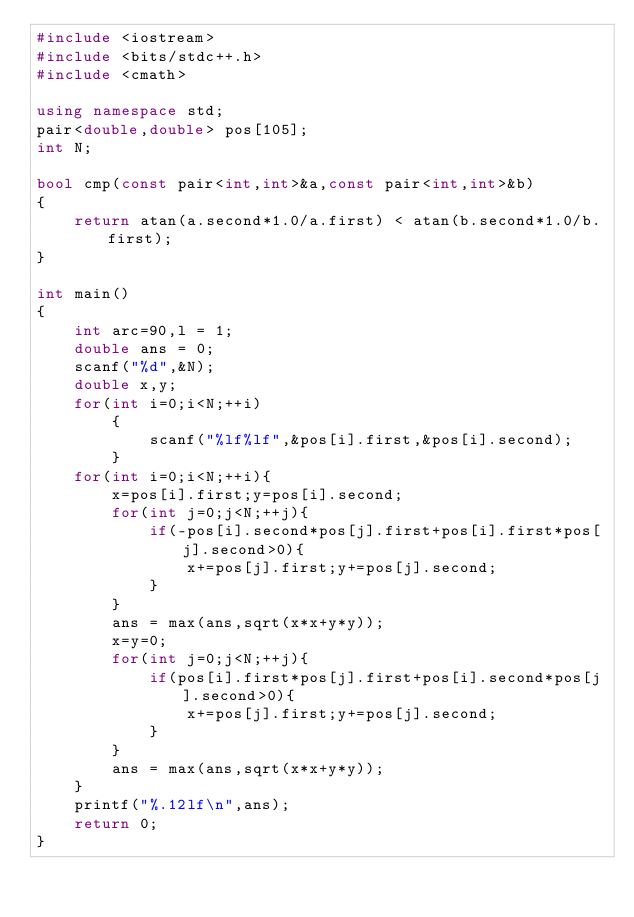<code> <loc_0><loc_0><loc_500><loc_500><_C++_>#include <iostream>
#include <bits/stdc++.h>
#include <cmath>

using namespace std;
pair<double,double> pos[105];
int N;

bool cmp(const pair<int,int>&a,const pair<int,int>&b)
{
    return atan(a.second*1.0/a.first) < atan(b.second*1.0/b.first);
}

int main()
{
    int arc=90,l = 1;
    double ans = 0;
    scanf("%d",&N);
    double x,y;
    for(int i=0;i<N;++i)
        {
            scanf("%lf%lf",&pos[i].first,&pos[i].second);
        }
    for(int i=0;i<N;++i){
        x=pos[i].first;y=pos[i].second;
        for(int j=0;j<N;++j){
            if(-pos[i].second*pos[j].first+pos[i].first*pos[j].second>0){
                x+=pos[j].first;y+=pos[j].second;
            }
        }
        ans = max(ans,sqrt(x*x+y*y));
        x=y=0;
        for(int j=0;j<N;++j){
            if(pos[i].first*pos[j].first+pos[i].second*pos[j].second>0){
                x+=pos[j].first;y+=pos[j].second;
            }
        }
        ans = max(ans,sqrt(x*x+y*y));
    }
    printf("%.12lf\n",ans);
    return 0;
}
</code> 